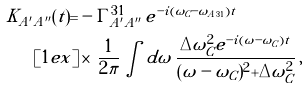<formula> <loc_0><loc_0><loc_500><loc_500>K _ { A ^ { \prime } A ^ { \prime \prime } } ( t ) = & - \Gamma _ { A ^ { \prime } A ^ { \prime \prime } } ^ { 3 1 } \, e ^ { - i ( \omega _ { C } - \tilde { \omega } _ { A 3 1 } ) t } \\ [ 1 e x ] & \times \, \frac { 1 } { 2 \pi } \int d \omega \, \frac { \Delta \omega _ { C } ^ { 2 } e ^ { - i ( \omega - \omega _ { C } ) t } } { ( \omega - \omega _ { C } ) ^ { 2 } + \Delta \omega _ { C } ^ { 2 } } \, ,</formula> 